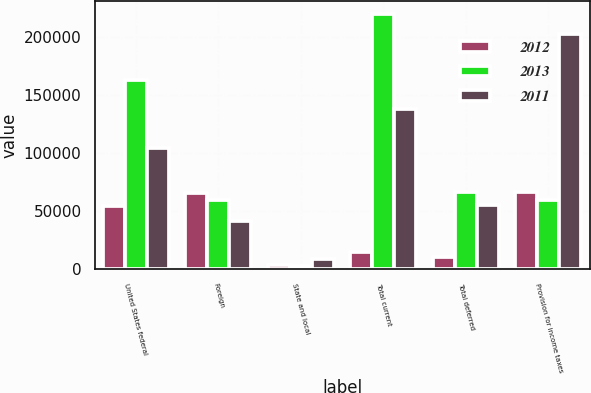Convert chart. <chart><loc_0><loc_0><loc_500><loc_500><stacked_bar_chart><ecel><fcel>United States federal<fcel>Foreign<fcel>State and local<fcel>Total current<fcel>Total deferred<fcel>Provision for income taxes<nl><fcel>2012<fcel>53985<fcel>65609<fcel>3317<fcel>14941<fcel>10596<fcel>66156<nl><fcel>2013<fcel>162574<fcel>59255<fcel>2244<fcel>219585<fcel>66434<fcel>59255<nl><fcel>2011<fcel>104587<fcel>41724<fcel>8769<fcel>137542<fcel>55273<fcel>202383<nl></chart> 